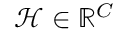Convert formula to latex. <formula><loc_0><loc_0><loc_500><loc_500>\mathcal { H } \in \mathbb { R } ^ { C }</formula> 